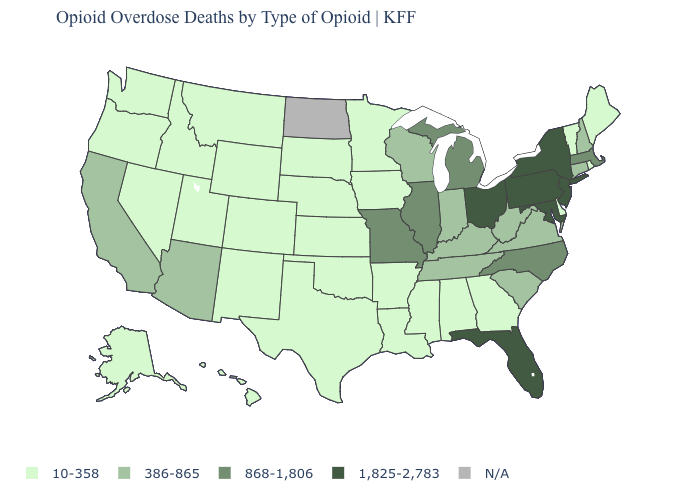What is the value of Tennessee?
Be succinct. 386-865. What is the value of Nebraska?
Short answer required. 10-358. Is the legend a continuous bar?
Quick response, please. No. Name the states that have a value in the range 868-1,806?
Write a very short answer. Illinois, Massachusetts, Michigan, Missouri, North Carolina. Name the states that have a value in the range 386-865?
Be succinct. Arizona, California, Connecticut, Indiana, Kentucky, New Hampshire, South Carolina, Tennessee, Virginia, West Virginia, Wisconsin. Name the states that have a value in the range 10-358?
Give a very brief answer. Alabama, Alaska, Arkansas, Colorado, Delaware, Georgia, Hawaii, Idaho, Iowa, Kansas, Louisiana, Maine, Minnesota, Mississippi, Montana, Nebraska, Nevada, New Mexico, Oklahoma, Oregon, Rhode Island, South Dakota, Texas, Utah, Vermont, Washington, Wyoming. Among the states that border Virginia , which have the highest value?
Write a very short answer. Maryland. What is the value of Georgia?
Write a very short answer. 10-358. Among the states that border Ohio , does Pennsylvania have the highest value?
Be succinct. Yes. Among the states that border Nebraska , which have the lowest value?
Give a very brief answer. Colorado, Iowa, Kansas, South Dakota, Wyoming. Name the states that have a value in the range 386-865?
Write a very short answer. Arizona, California, Connecticut, Indiana, Kentucky, New Hampshire, South Carolina, Tennessee, Virginia, West Virginia, Wisconsin. Name the states that have a value in the range 10-358?
Quick response, please. Alabama, Alaska, Arkansas, Colorado, Delaware, Georgia, Hawaii, Idaho, Iowa, Kansas, Louisiana, Maine, Minnesota, Mississippi, Montana, Nebraska, Nevada, New Mexico, Oklahoma, Oregon, Rhode Island, South Dakota, Texas, Utah, Vermont, Washington, Wyoming. Among the states that border Wyoming , which have the lowest value?
Answer briefly. Colorado, Idaho, Montana, Nebraska, South Dakota, Utah. 